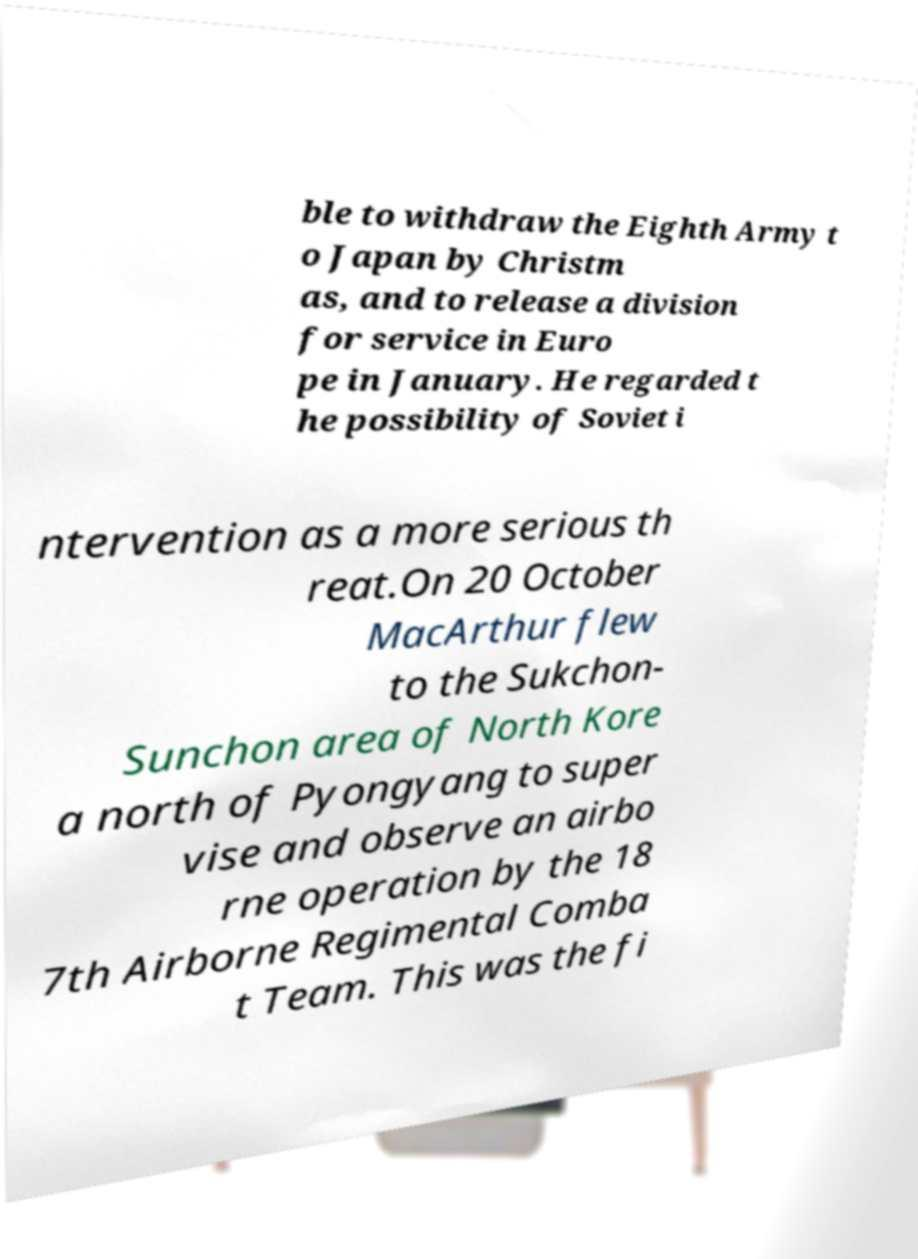Could you extract and type out the text from this image? ble to withdraw the Eighth Army t o Japan by Christm as, and to release a division for service in Euro pe in January. He regarded t he possibility of Soviet i ntervention as a more serious th reat.On 20 October MacArthur flew to the Sukchon- Sunchon area of North Kore a north of Pyongyang to super vise and observe an airbo rne operation by the 18 7th Airborne Regimental Comba t Team. This was the fi 